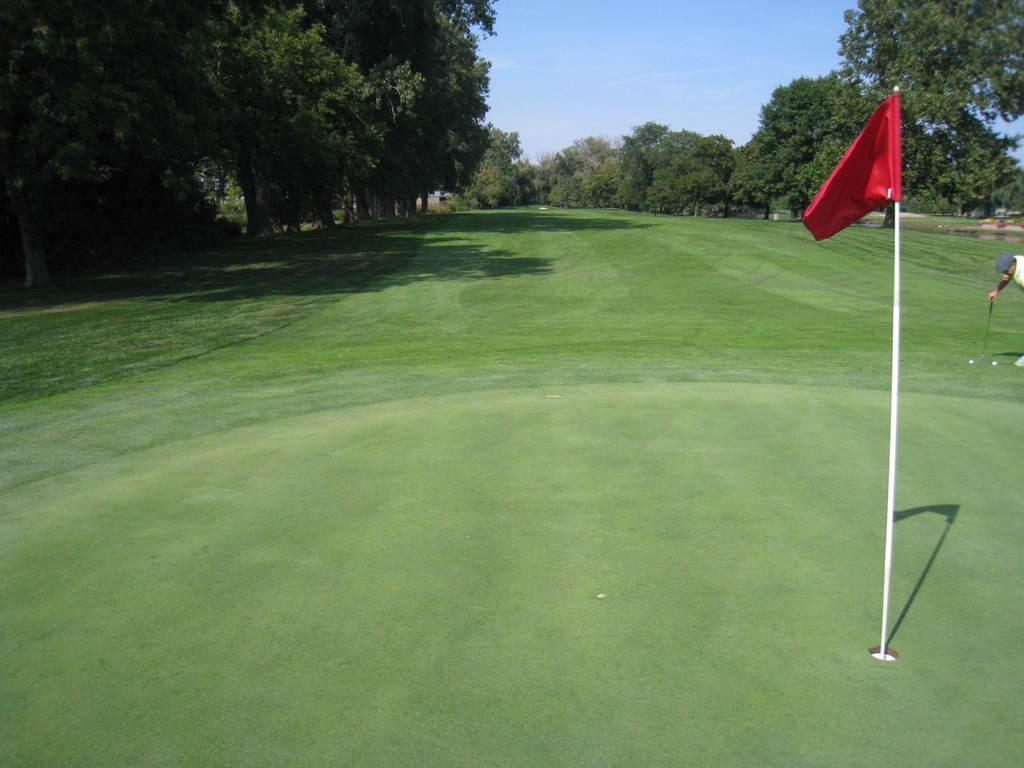Could you give a brief overview of what you see in this image? In this image in front there is a flag. On the right side of the image there is a person holding the stick. In front of him there are two balls. In the background of the image there are trees and sky. At the bottom of the image there is grass on the surface. 